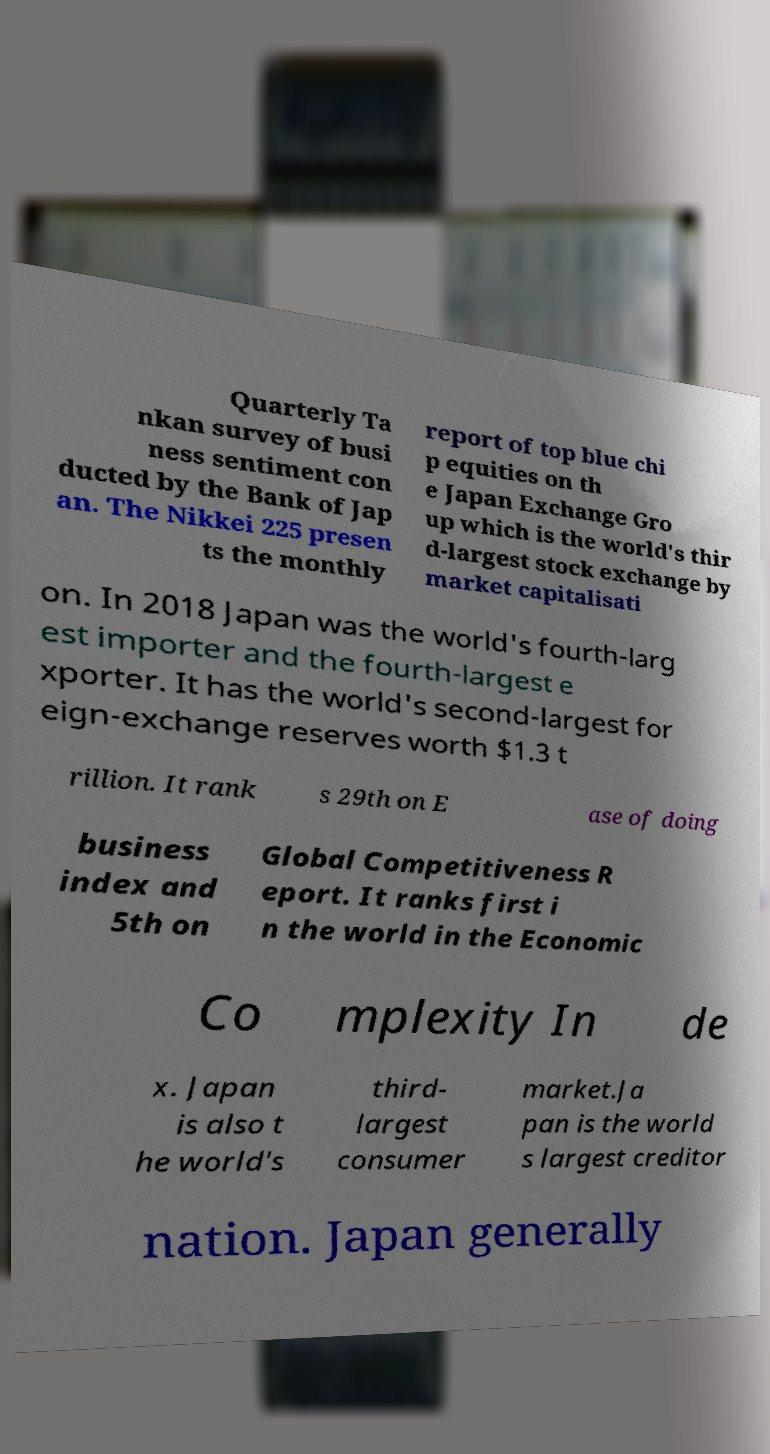Could you extract and type out the text from this image? Quarterly Ta nkan survey of busi ness sentiment con ducted by the Bank of Jap an. The Nikkei 225 presen ts the monthly report of top blue chi p equities on th e Japan Exchange Gro up which is the world's thir d-largest stock exchange by market capitalisati on. In 2018 Japan was the world's fourth-larg est importer and the fourth-largest e xporter. It has the world's second-largest for eign-exchange reserves worth $1.3 t rillion. It rank s 29th on E ase of doing business index and 5th on Global Competitiveness R eport. It ranks first i n the world in the Economic Co mplexity In de x. Japan is also t he world's third- largest consumer market.Ja pan is the world s largest creditor nation. Japan generally 